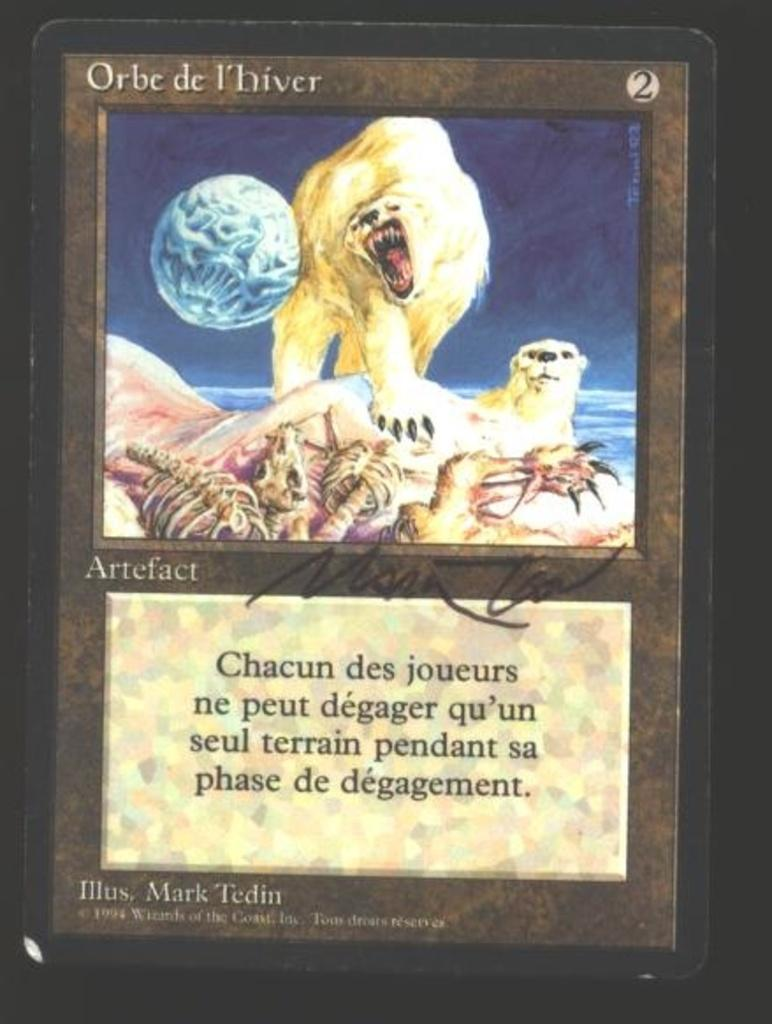What is present in the image that features a design or message? There is a poster in the image. What type of images can be seen on the poster? The poster contains animals. Are there any words or phrases on the poster? Yes, there is text on the poster. Where is the grandmother standing in the image? There is no grandmother present in the image; it only features a poster with animals and text. 